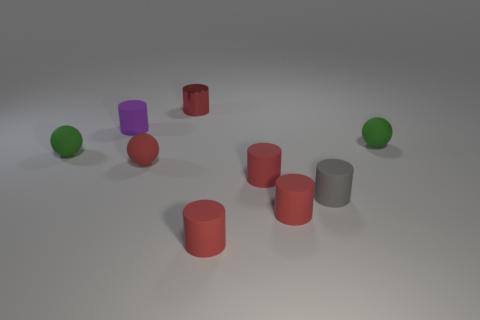Subtract all gray blocks. How many red cylinders are left? 4 Subtract 2 cylinders. How many cylinders are left? 4 Subtract all purple cylinders. How many cylinders are left? 5 Subtract all small gray cylinders. How many cylinders are left? 5 Subtract all gray cylinders. Subtract all green cubes. How many cylinders are left? 5 Subtract all cylinders. How many objects are left? 3 Add 7 small green things. How many small green things exist? 9 Subtract 0 green cylinders. How many objects are left? 9 Subtract all tiny cyan matte balls. Subtract all tiny matte spheres. How many objects are left? 6 Add 9 gray things. How many gray things are left? 10 